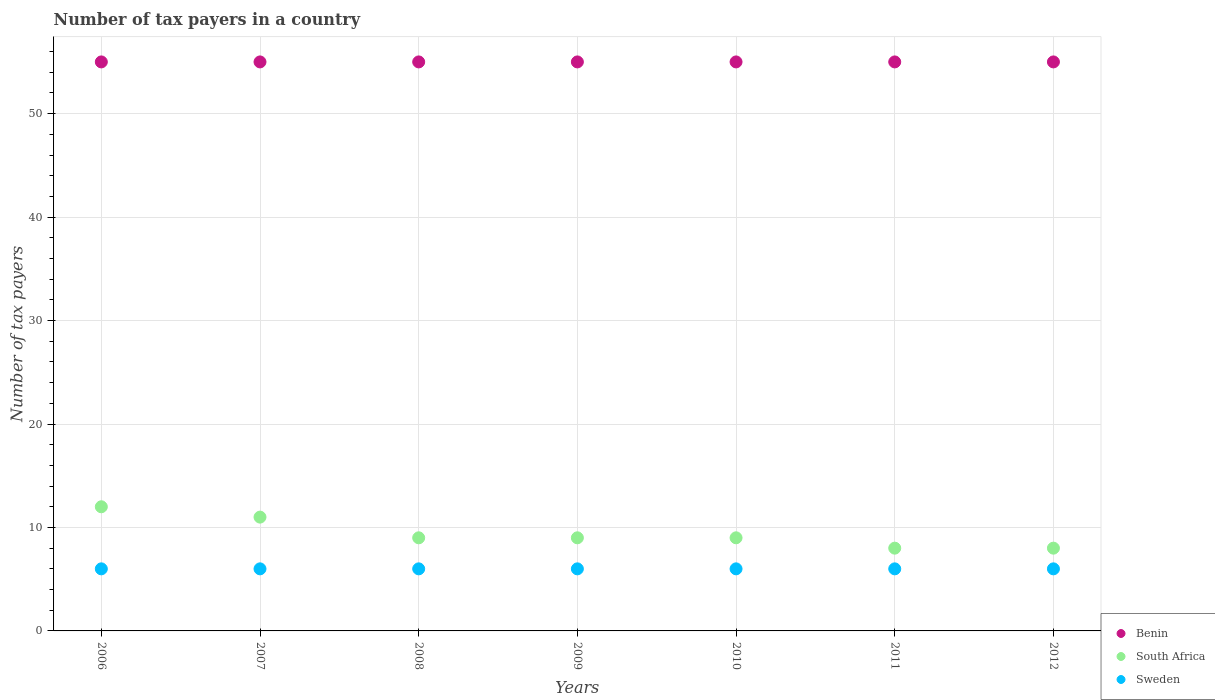How many different coloured dotlines are there?
Your answer should be very brief. 3. Is the number of dotlines equal to the number of legend labels?
Offer a very short reply. Yes. What is the number of tax payers in in South Africa in 2006?
Give a very brief answer. 12. Across all years, what is the maximum number of tax payers in in South Africa?
Make the answer very short. 12. Across all years, what is the minimum number of tax payers in in Benin?
Your answer should be very brief. 55. In which year was the number of tax payers in in Sweden minimum?
Your answer should be compact. 2006. What is the total number of tax payers in in South Africa in the graph?
Your response must be concise. 66. What is the difference between the number of tax payers in in Benin in 2009 and that in 2010?
Provide a succinct answer. 0. What is the difference between the number of tax payers in in South Africa in 2007 and the number of tax payers in in Benin in 2009?
Make the answer very short. -44. In the year 2011, what is the difference between the number of tax payers in in Sweden and number of tax payers in in South Africa?
Make the answer very short. -2. In how many years, is the number of tax payers in in South Africa greater than 14?
Offer a terse response. 0. What is the ratio of the number of tax payers in in Sweden in 2006 to that in 2009?
Make the answer very short. 1. Is the number of tax payers in in South Africa in 2008 less than that in 2011?
Ensure brevity in your answer.  No. Is the difference between the number of tax payers in in Sweden in 2007 and 2009 greater than the difference between the number of tax payers in in South Africa in 2007 and 2009?
Your answer should be very brief. No. Is the sum of the number of tax payers in in Sweden in 2008 and 2010 greater than the maximum number of tax payers in in South Africa across all years?
Your response must be concise. No. Is the number of tax payers in in South Africa strictly less than the number of tax payers in in Benin over the years?
Your answer should be compact. Yes. How many years are there in the graph?
Provide a succinct answer. 7. Does the graph contain grids?
Your response must be concise. Yes. How are the legend labels stacked?
Your answer should be very brief. Vertical. What is the title of the graph?
Provide a succinct answer. Number of tax payers in a country. Does "Switzerland" appear as one of the legend labels in the graph?
Your response must be concise. No. What is the label or title of the Y-axis?
Provide a short and direct response. Number of tax payers. What is the Number of tax payers in Benin in 2006?
Your response must be concise. 55. What is the Number of tax payers of Sweden in 2006?
Make the answer very short. 6. What is the Number of tax payers in Benin in 2009?
Offer a very short reply. 55. What is the Number of tax payers of Benin in 2010?
Offer a very short reply. 55. What is the Number of tax payers in South Africa in 2011?
Offer a terse response. 8. What is the Number of tax payers of Benin in 2012?
Give a very brief answer. 55. What is the Number of tax payers in South Africa in 2012?
Provide a succinct answer. 8. What is the Number of tax payers of Sweden in 2012?
Provide a short and direct response. 6. Across all years, what is the maximum Number of tax payers of South Africa?
Make the answer very short. 12. Across all years, what is the minimum Number of tax payers of Sweden?
Provide a short and direct response. 6. What is the total Number of tax payers in Benin in the graph?
Provide a succinct answer. 385. What is the total Number of tax payers in South Africa in the graph?
Your response must be concise. 66. What is the total Number of tax payers in Sweden in the graph?
Provide a succinct answer. 42. What is the difference between the Number of tax payers of Benin in 2006 and that in 2007?
Provide a short and direct response. 0. What is the difference between the Number of tax payers in South Africa in 2006 and that in 2007?
Ensure brevity in your answer.  1. What is the difference between the Number of tax payers in Sweden in 2006 and that in 2007?
Make the answer very short. 0. What is the difference between the Number of tax payers in Sweden in 2006 and that in 2008?
Your response must be concise. 0. What is the difference between the Number of tax payers of South Africa in 2006 and that in 2009?
Provide a succinct answer. 3. What is the difference between the Number of tax payers of Benin in 2006 and that in 2010?
Provide a short and direct response. 0. What is the difference between the Number of tax payers in South Africa in 2006 and that in 2010?
Provide a short and direct response. 3. What is the difference between the Number of tax payers of Sweden in 2006 and that in 2011?
Your response must be concise. 0. What is the difference between the Number of tax payers in South Africa in 2006 and that in 2012?
Provide a short and direct response. 4. What is the difference between the Number of tax payers in South Africa in 2007 and that in 2008?
Your answer should be very brief. 2. What is the difference between the Number of tax payers of Sweden in 2007 and that in 2008?
Ensure brevity in your answer.  0. What is the difference between the Number of tax payers in Benin in 2007 and that in 2009?
Give a very brief answer. 0. What is the difference between the Number of tax payers in Sweden in 2007 and that in 2009?
Keep it short and to the point. 0. What is the difference between the Number of tax payers of Benin in 2007 and that in 2010?
Ensure brevity in your answer.  0. What is the difference between the Number of tax payers in Benin in 2007 and that in 2011?
Ensure brevity in your answer.  0. What is the difference between the Number of tax payers of South Africa in 2007 and that in 2011?
Make the answer very short. 3. What is the difference between the Number of tax payers of Sweden in 2007 and that in 2011?
Make the answer very short. 0. What is the difference between the Number of tax payers of Benin in 2007 and that in 2012?
Offer a very short reply. 0. What is the difference between the Number of tax payers of Sweden in 2007 and that in 2012?
Your answer should be very brief. 0. What is the difference between the Number of tax payers of Benin in 2008 and that in 2010?
Make the answer very short. 0. What is the difference between the Number of tax payers of Sweden in 2008 and that in 2010?
Offer a very short reply. 0. What is the difference between the Number of tax payers of South Africa in 2008 and that in 2011?
Keep it short and to the point. 1. What is the difference between the Number of tax payers of Sweden in 2008 and that in 2011?
Your response must be concise. 0. What is the difference between the Number of tax payers in Benin in 2008 and that in 2012?
Offer a very short reply. 0. What is the difference between the Number of tax payers of Sweden in 2008 and that in 2012?
Offer a very short reply. 0. What is the difference between the Number of tax payers of Benin in 2009 and that in 2011?
Offer a very short reply. 0. What is the difference between the Number of tax payers of Sweden in 2009 and that in 2012?
Provide a short and direct response. 0. What is the difference between the Number of tax payers in South Africa in 2010 and that in 2011?
Provide a short and direct response. 1. What is the difference between the Number of tax payers in Benin in 2010 and that in 2012?
Your response must be concise. 0. What is the difference between the Number of tax payers in South Africa in 2010 and that in 2012?
Give a very brief answer. 1. What is the difference between the Number of tax payers in South Africa in 2011 and that in 2012?
Make the answer very short. 0. What is the difference between the Number of tax payers of South Africa in 2006 and the Number of tax payers of Sweden in 2007?
Ensure brevity in your answer.  6. What is the difference between the Number of tax payers in Benin in 2006 and the Number of tax payers in South Africa in 2009?
Provide a short and direct response. 46. What is the difference between the Number of tax payers in South Africa in 2006 and the Number of tax payers in Sweden in 2009?
Provide a short and direct response. 6. What is the difference between the Number of tax payers in Benin in 2006 and the Number of tax payers in South Africa in 2010?
Ensure brevity in your answer.  46. What is the difference between the Number of tax payers in Benin in 2006 and the Number of tax payers in Sweden in 2010?
Offer a terse response. 49. What is the difference between the Number of tax payers in Benin in 2006 and the Number of tax payers in Sweden in 2011?
Keep it short and to the point. 49. What is the difference between the Number of tax payers in Benin in 2006 and the Number of tax payers in South Africa in 2012?
Your answer should be very brief. 47. What is the difference between the Number of tax payers in South Africa in 2006 and the Number of tax payers in Sweden in 2012?
Your answer should be compact. 6. What is the difference between the Number of tax payers of Benin in 2007 and the Number of tax payers of South Africa in 2009?
Provide a succinct answer. 46. What is the difference between the Number of tax payers in South Africa in 2007 and the Number of tax payers in Sweden in 2009?
Provide a short and direct response. 5. What is the difference between the Number of tax payers of Benin in 2007 and the Number of tax payers of South Africa in 2010?
Your answer should be compact. 46. What is the difference between the Number of tax payers in Benin in 2007 and the Number of tax payers in Sweden in 2010?
Offer a terse response. 49. What is the difference between the Number of tax payers in South Africa in 2007 and the Number of tax payers in Sweden in 2011?
Offer a terse response. 5. What is the difference between the Number of tax payers in Benin in 2007 and the Number of tax payers in Sweden in 2012?
Give a very brief answer. 49. What is the difference between the Number of tax payers of Benin in 2008 and the Number of tax payers of Sweden in 2009?
Your answer should be very brief. 49. What is the difference between the Number of tax payers in Benin in 2008 and the Number of tax payers in South Africa in 2010?
Make the answer very short. 46. What is the difference between the Number of tax payers in Benin in 2008 and the Number of tax payers in South Africa in 2012?
Provide a short and direct response. 47. What is the difference between the Number of tax payers of Benin in 2009 and the Number of tax payers of Sweden in 2010?
Provide a succinct answer. 49. What is the difference between the Number of tax payers of South Africa in 2009 and the Number of tax payers of Sweden in 2010?
Offer a terse response. 3. What is the difference between the Number of tax payers of Benin in 2009 and the Number of tax payers of South Africa in 2011?
Make the answer very short. 47. What is the difference between the Number of tax payers of Benin in 2009 and the Number of tax payers of South Africa in 2012?
Give a very brief answer. 47. What is the difference between the Number of tax payers in Benin in 2009 and the Number of tax payers in Sweden in 2012?
Your answer should be compact. 49. What is the difference between the Number of tax payers in Benin in 2010 and the Number of tax payers in South Africa in 2011?
Your response must be concise. 47. What is the difference between the Number of tax payers in Benin in 2010 and the Number of tax payers in Sweden in 2011?
Give a very brief answer. 49. What is the difference between the Number of tax payers in Benin in 2010 and the Number of tax payers in South Africa in 2012?
Ensure brevity in your answer.  47. What is the difference between the Number of tax payers in Benin in 2011 and the Number of tax payers in South Africa in 2012?
Make the answer very short. 47. What is the difference between the Number of tax payers of Benin in 2011 and the Number of tax payers of Sweden in 2012?
Offer a terse response. 49. What is the difference between the Number of tax payers in South Africa in 2011 and the Number of tax payers in Sweden in 2012?
Your response must be concise. 2. What is the average Number of tax payers of South Africa per year?
Make the answer very short. 9.43. In the year 2006, what is the difference between the Number of tax payers of South Africa and Number of tax payers of Sweden?
Give a very brief answer. 6. In the year 2008, what is the difference between the Number of tax payers of Benin and Number of tax payers of Sweden?
Offer a very short reply. 49. In the year 2009, what is the difference between the Number of tax payers of Benin and Number of tax payers of Sweden?
Offer a terse response. 49. In the year 2010, what is the difference between the Number of tax payers of Benin and Number of tax payers of Sweden?
Provide a succinct answer. 49. In the year 2010, what is the difference between the Number of tax payers of South Africa and Number of tax payers of Sweden?
Your answer should be compact. 3. In the year 2011, what is the difference between the Number of tax payers of Benin and Number of tax payers of South Africa?
Your answer should be compact. 47. In the year 2011, what is the difference between the Number of tax payers of Benin and Number of tax payers of Sweden?
Keep it short and to the point. 49. In the year 2011, what is the difference between the Number of tax payers of South Africa and Number of tax payers of Sweden?
Offer a terse response. 2. In the year 2012, what is the difference between the Number of tax payers in Benin and Number of tax payers in Sweden?
Make the answer very short. 49. What is the ratio of the Number of tax payers in Benin in 2006 to that in 2007?
Your answer should be compact. 1. What is the ratio of the Number of tax payers of Sweden in 2006 to that in 2007?
Your answer should be compact. 1. What is the ratio of the Number of tax payers in South Africa in 2006 to that in 2008?
Provide a succinct answer. 1.33. What is the ratio of the Number of tax payers in Sweden in 2006 to that in 2008?
Offer a very short reply. 1. What is the ratio of the Number of tax payers of Benin in 2006 to that in 2009?
Your answer should be compact. 1. What is the ratio of the Number of tax payers in Sweden in 2006 to that in 2009?
Offer a very short reply. 1. What is the ratio of the Number of tax payers in Sweden in 2006 to that in 2010?
Give a very brief answer. 1. What is the ratio of the Number of tax payers of Benin in 2006 to that in 2011?
Give a very brief answer. 1. What is the ratio of the Number of tax payers in South Africa in 2006 to that in 2011?
Provide a succinct answer. 1.5. What is the ratio of the Number of tax payers in Sweden in 2006 to that in 2011?
Offer a terse response. 1. What is the ratio of the Number of tax payers in South Africa in 2006 to that in 2012?
Provide a short and direct response. 1.5. What is the ratio of the Number of tax payers of South Africa in 2007 to that in 2008?
Offer a very short reply. 1.22. What is the ratio of the Number of tax payers in South Africa in 2007 to that in 2009?
Ensure brevity in your answer.  1.22. What is the ratio of the Number of tax payers of Sweden in 2007 to that in 2009?
Provide a succinct answer. 1. What is the ratio of the Number of tax payers of Benin in 2007 to that in 2010?
Ensure brevity in your answer.  1. What is the ratio of the Number of tax payers of South Africa in 2007 to that in 2010?
Keep it short and to the point. 1.22. What is the ratio of the Number of tax payers of South Africa in 2007 to that in 2011?
Offer a terse response. 1.38. What is the ratio of the Number of tax payers in Sweden in 2007 to that in 2011?
Ensure brevity in your answer.  1. What is the ratio of the Number of tax payers of Benin in 2007 to that in 2012?
Provide a short and direct response. 1. What is the ratio of the Number of tax payers in South Africa in 2007 to that in 2012?
Give a very brief answer. 1.38. What is the ratio of the Number of tax payers of South Africa in 2008 to that in 2009?
Your answer should be very brief. 1. What is the ratio of the Number of tax payers of Benin in 2008 to that in 2010?
Keep it short and to the point. 1. What is the ratio of the Number of tax payers of Sweden in 2008 to that in 2010?
Offer a very short reply. 1. What is the ratio of the Number of tax payers of Benin in 2008 to that in 2011?
Keep it short and to the point. 1. What is the ratio of the Number of tax payers in South Africa in 2008 to that in 2011?
Offer a terse response. 1.12. What is the ratio of the Number of tax payers of Benin in 2008 to that in 2012?
Your answer should be very brief. 1. What is the ratio of the Number of tax payers in South Africa in 2008 to that in 2012?
Provide a short and direct response. 1.12. What is the ratio of the Number of tax payers in Benin in 2009 to that in 2010?
Your answer should be very brief. 1. What is the ratio of the Number of tax payers of South Africa in 2009 to that in 2010?
Make the answer very short. 1. What is the ratio of the Number of tax payers in Sweden in 2009 to that in 2010?
Provide a succinct answer. 1. What is the ratio of the Number of tax payers of South Africa in 2009 to that in 2012?
Give a very brief answer. 1.12. What is the ratio of the Number of tax payers of Sweden in 2009 to that in 2012?
Your response must be concise. 1. What is the ratio of the Number of tax payers in Sweden in 2010 to that in 2011?
Your answer should be very brief. 1. What is the ratio of the Number of tax payers of Benin in 2010 to that in 2012?
Offer a terse response. 1. What is the ratio of the Number of tax payers of South Africa in 2010 to that in 2012?
Your answer should be compact. 1.12. What is the ratio of the Number of tax payers in Sweden in 2010 to that in 2012?
Your answer should be compact. 1. What is the ratio of the Number of tax payers of Benin in 2011 to that in 2012?
Keep it short and to the point. 1. What is the ratio of the Number of tax payers of Sweden in 2011 to that in 2012?
Provide a succinct answer. 1. What is the difference between the highest and the second highest Number of tax payers of Benin?
Ensure brevity in your answer.  0. What is the difference between the highest and the lowest Number of tax payers of South Africa?
Your answer should be compact. 4. What is the difference between the highest and the lowest Number of tax payers in Sweden?
Ensure brevity in your answer.  0. 